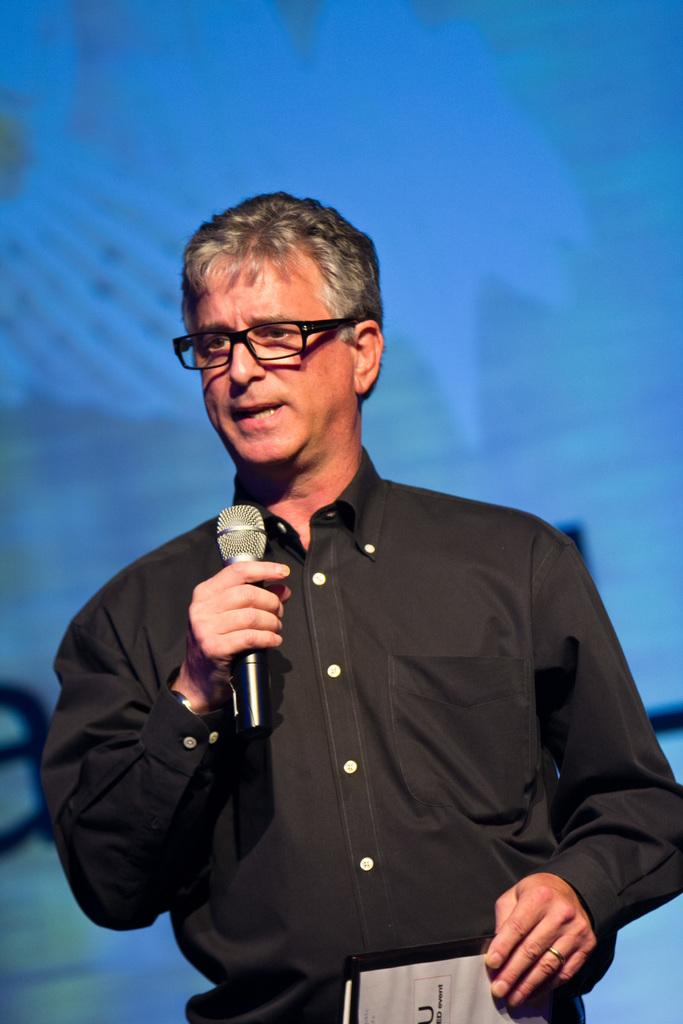What is the man in the image doing? The man is standing and speaking in the image. What is the man holding in his hands? The man is holding a microphone and another object in his hands. What can be seen in the background of the image? There is a screen in the background of the image. What is the value of the appliance on the screen in the image? There is no appliance visible on the screen in the image, and therefore no value can be determined. 